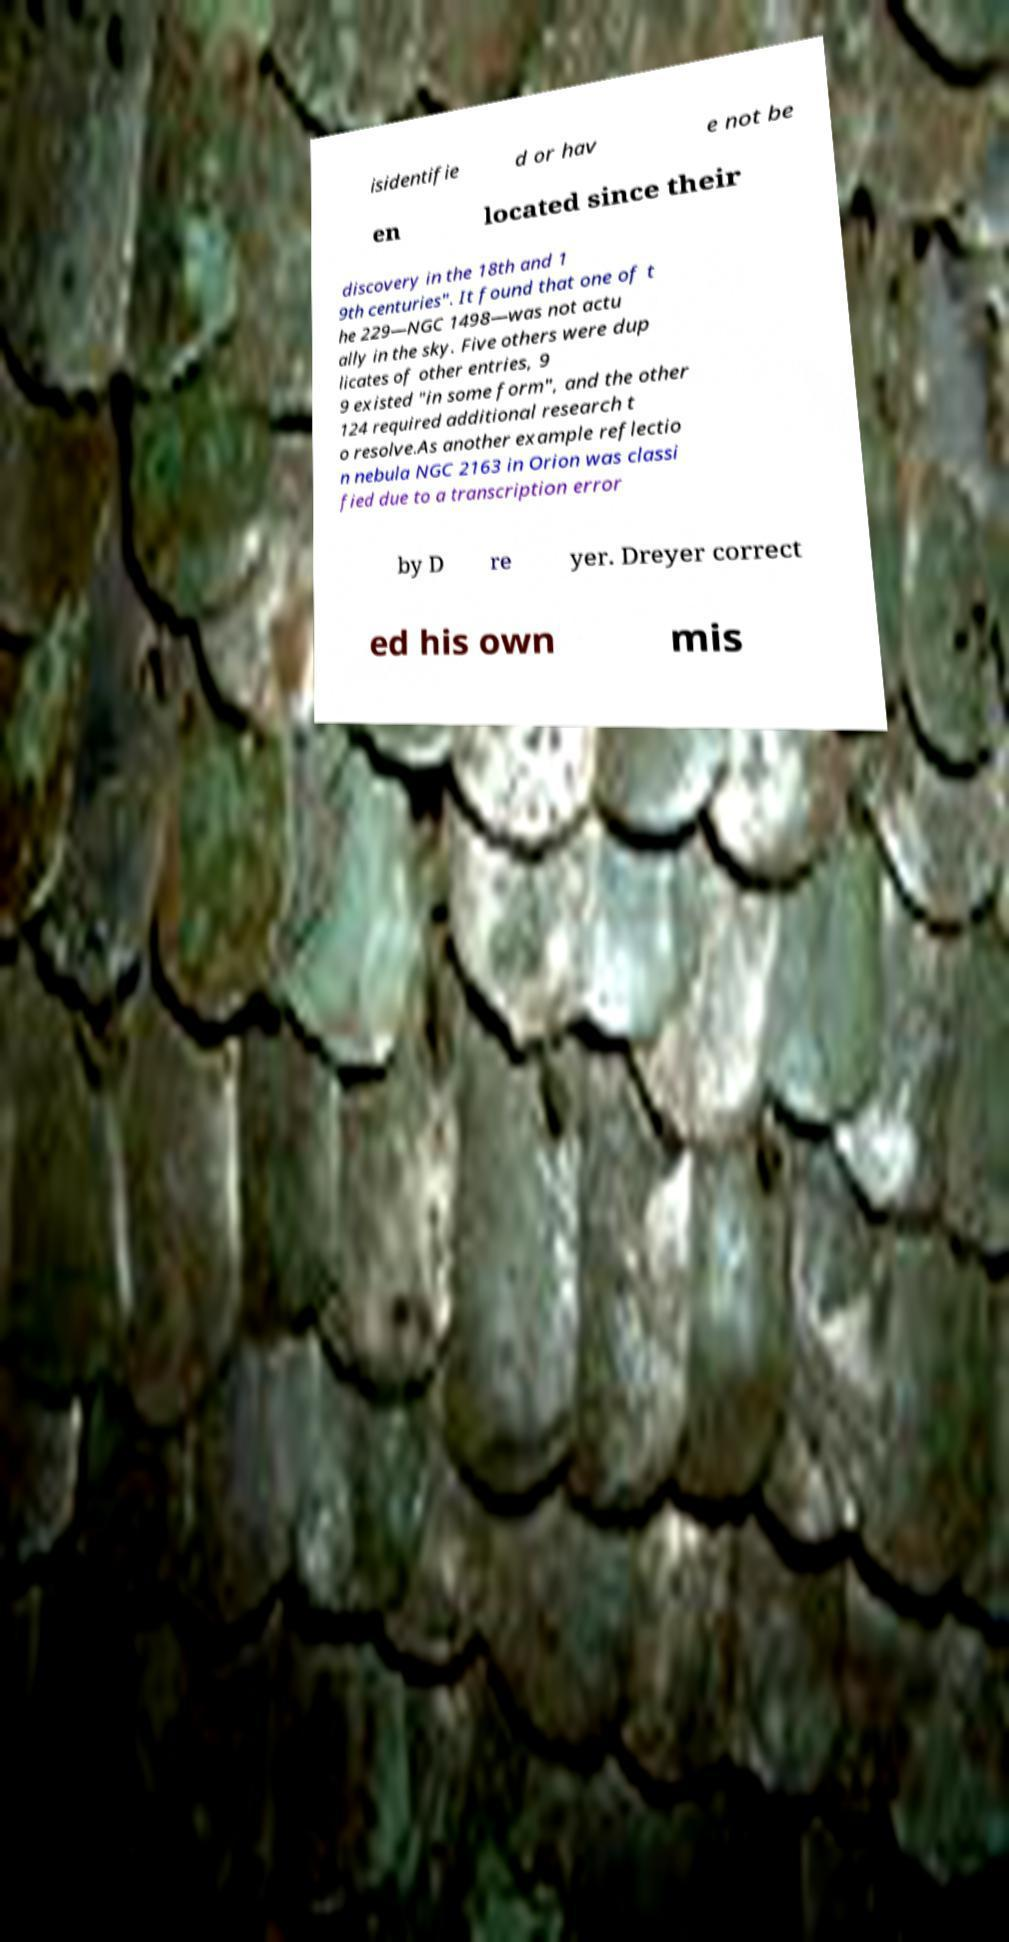I need the written content from this picture converted into text. Can you do that? isidentifie d or hav e not be en located since their discovery in the 18th and 1 9th centuries". It found that one of t he 229—NGC 1498—was not actu ally in the sky. Five others were dup licates of other entries, 9 9 existed "in some form", and the other 124 required additional research t o resolve.As another example reflectio n nebula NGC 2163 in Orion was classi fied due to a transcription error by D re yer. Dreyer correct ed his own mis 